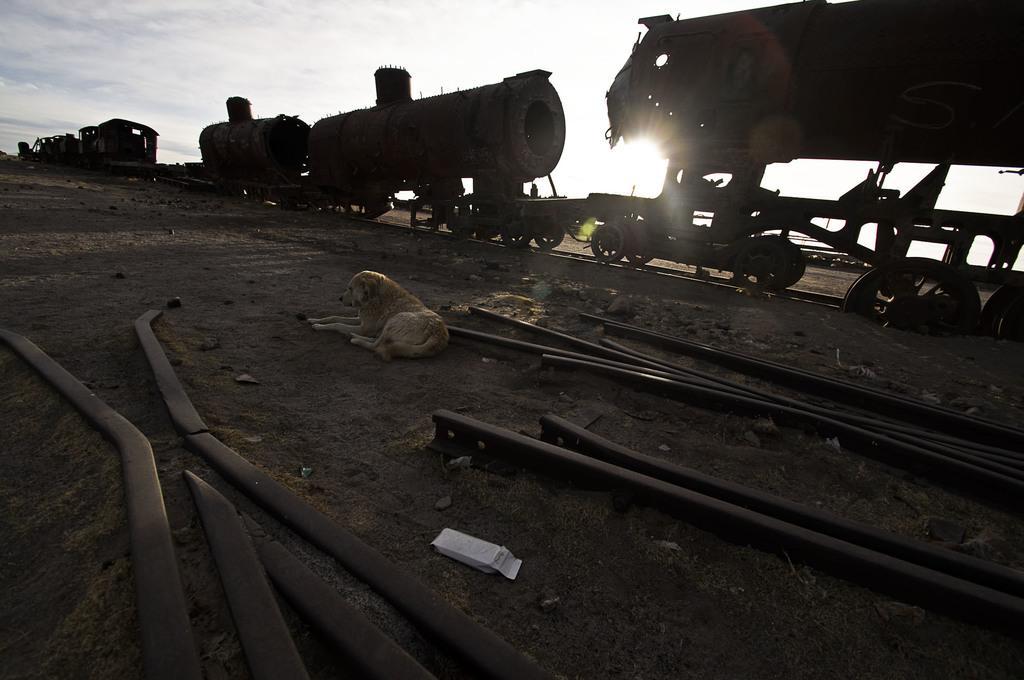Describe this image in one or two sentences. This image is taken outdoors. At the bottom of the image there is a ground and there are a few iron bars on the ground. At the top of the image there is a sky with clouds. In the middle of the image a train is moving on the track and there is a dog on the ground. 